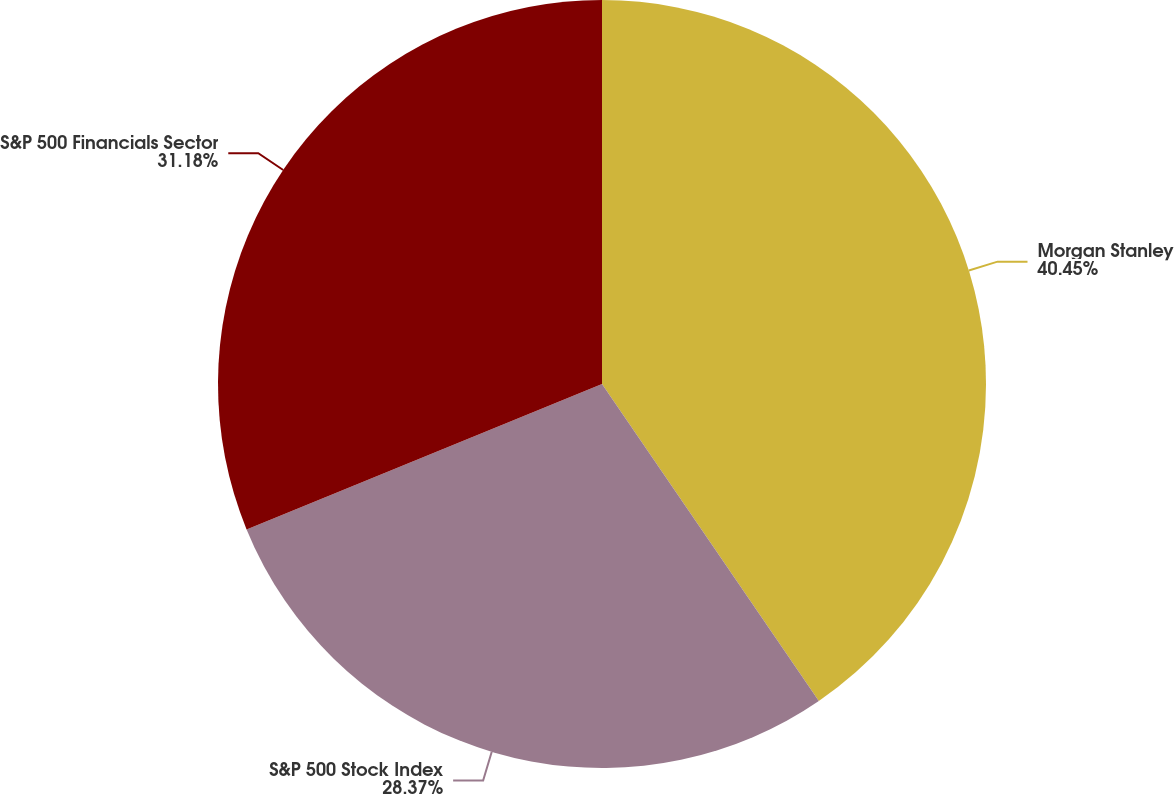Convert chart to OTSL. <chart><loc_0><loc_0><loc_500><loc_500><pie_chart><fcel>Morgan Stanley<fcel>S&P 500 Stock Index<fcel>S&P 500 Financials Sector<nl><fcel>40.45%<fcel>28.37%<fcel>31.18%<nl></chart> 